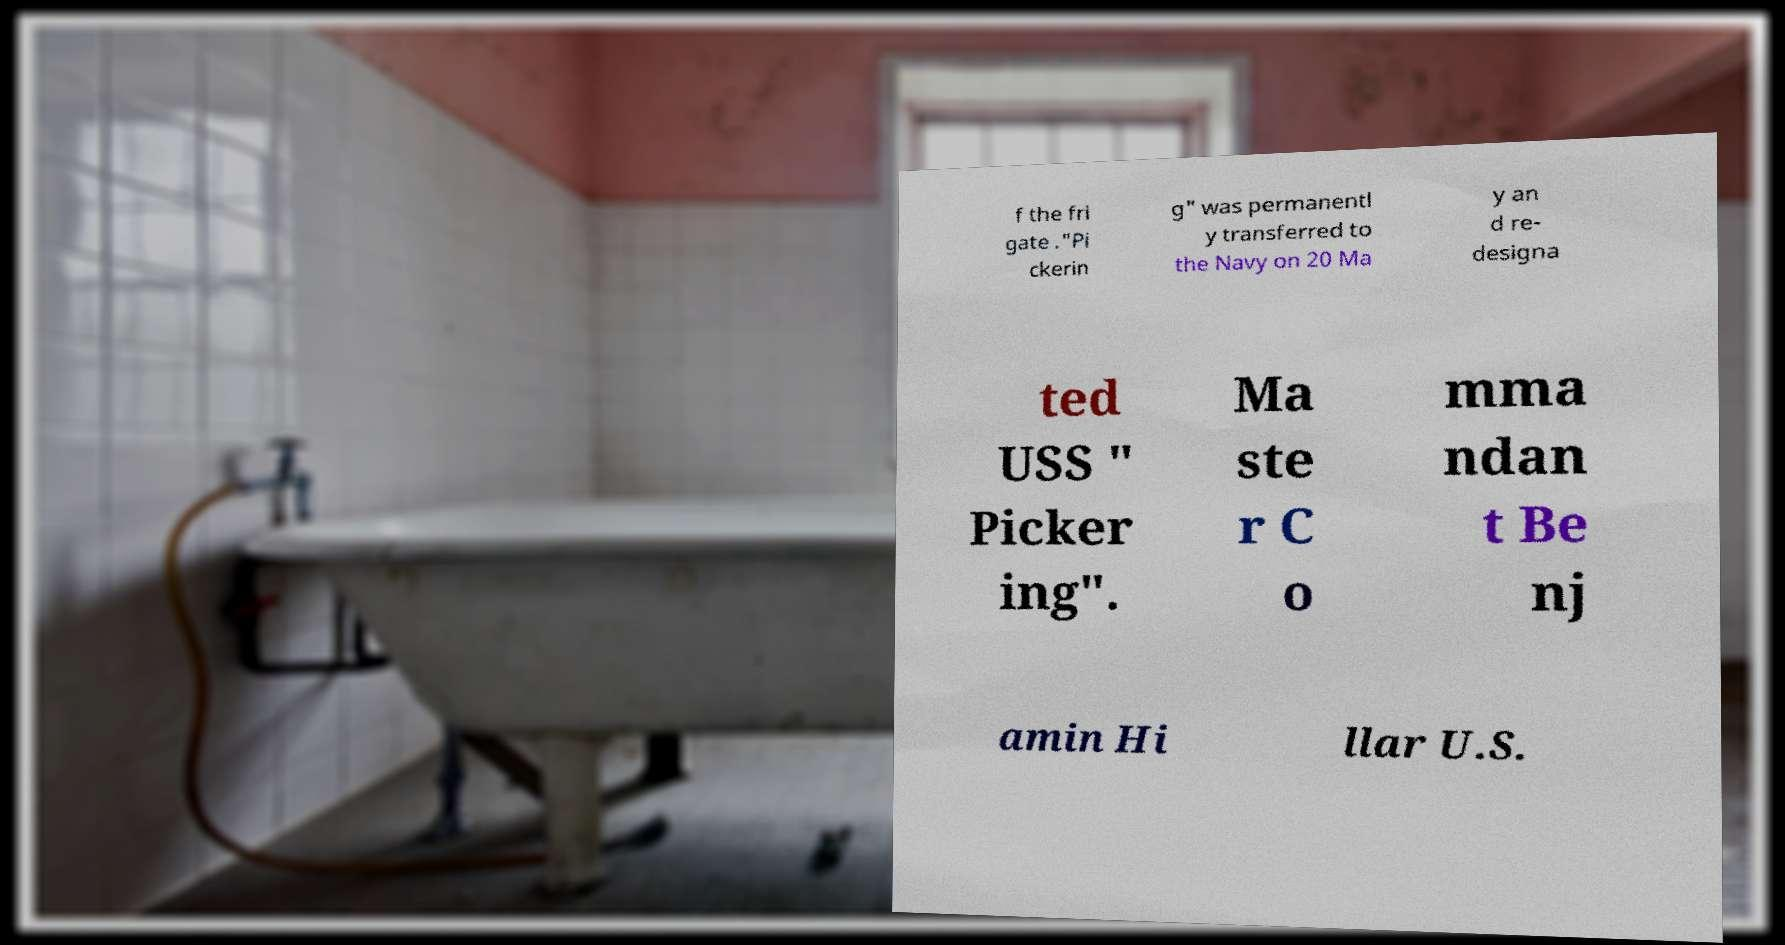Can you accurately transcribe the text from the provided image for me? f the fri gate ."Pi ckerin g" was permanentl y transferred to the Navy on 20 Ma y an d re- designa ted USS " Picker ing". Ma ste r C o mma ndan t Be nj amin Hi llar U.S. 